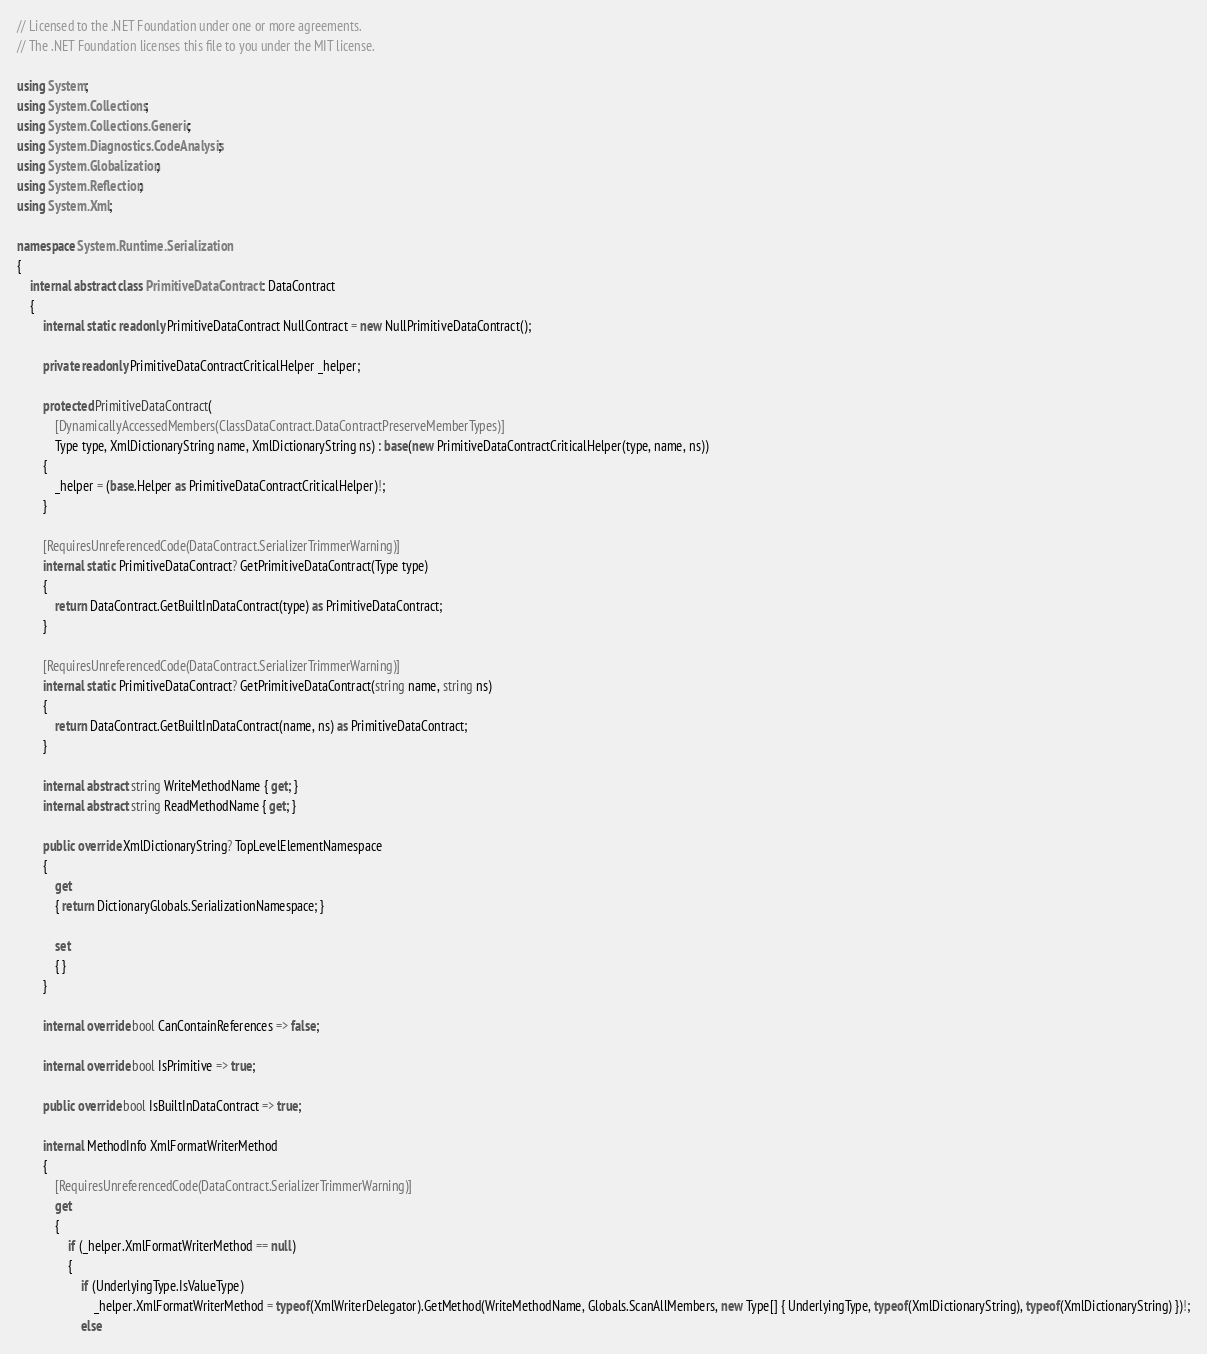Convert code to text. <code><loc_0><loc_0><loc_500><loc_500><_C#_>// Licensed to the .NET Foundation under one or more agreements.
// The .NET Foundation licenses this file to you under the MIT license.

using System;
using System.Collections;
using System.Collections.Generic;
using System.Diagnostics.CodeAnalysis;
using System.Globalization;
using System.Reflection;
using System.Xml;

namespace System.Runtime.Serialization
{
    internal abstract class PrimitiveDataContract : DataContract
    {
        internal static readonly PrimitiveDataContract NullContract = new NullPrimitiveDataContract();

        private readonly PrimitiveDataContractCriticalHelper _helper;

        protected PrimitiveDataContract(
            [DynamicallyAccessedMembers(ClassDataContract.DataContractPreserveMemberTypes)]
            Type type, XmlDictionaryString name, XmlDictionaryString ns) : base(new PrimitiveDataContractCriticalHelper(type, name, ns))
        {
            _helper = (base.Helper as PrimitiveDataContractCriticalHelper)!;
        }

        [RequiresUnreferencedCode(DataContract.SerializerTrimmerWarning)]
        internal static PrimitiveDataContract? GetPrimitiveDataContract(Type type)
        {
            return DataContract.GetBuiltInDataContract(type) as PrimitiveDataContract;
        }

        [RequiresUnreferencedCode(DataContract.SerializerTrimmerWarning)]
        internal static PrimitiveDataContract? GetPrimitiveDataContract(string name, string ns)
        {
            return DataContract.GetBuiltInDataContract(name, ns) as PrimitiveDataContract;
        }

        internal abstract string WriteMethodName { get; }
        internal abstract string ReadMethodName { get; }

        public override XmlDictionaryString? TopLevelElementNamespace
        {
            get
            { return DictionaryGlobals.SerializationNamespace; }

            set
            { }
        }

        internal override bool CanContainReferences => false;

        internal override bool IsPrimitive => true;

        public override bool IsBuiltInDataContract => true;

        internal MethodInfo XmlFormatWriterMethod
        {
            [RequiresUnreferencedCode(DataContract.SerializerTrimmerWarning)]
            get
            {
                if (_helper.XmlFormatWriterMethod == null)
                {
                    if (UnderlyingType.IsValueType)
                        _helper.XmlFormatWriterMethod = typeof(XmlWriterDelegator).GetMethod(WriteMethodName, Globals.ScanAllMembers, new Type[] { UnderlyingType, typeof(XmlDictionaryString), typeof(XmlDictionaryString) })!;
                    else</code> 